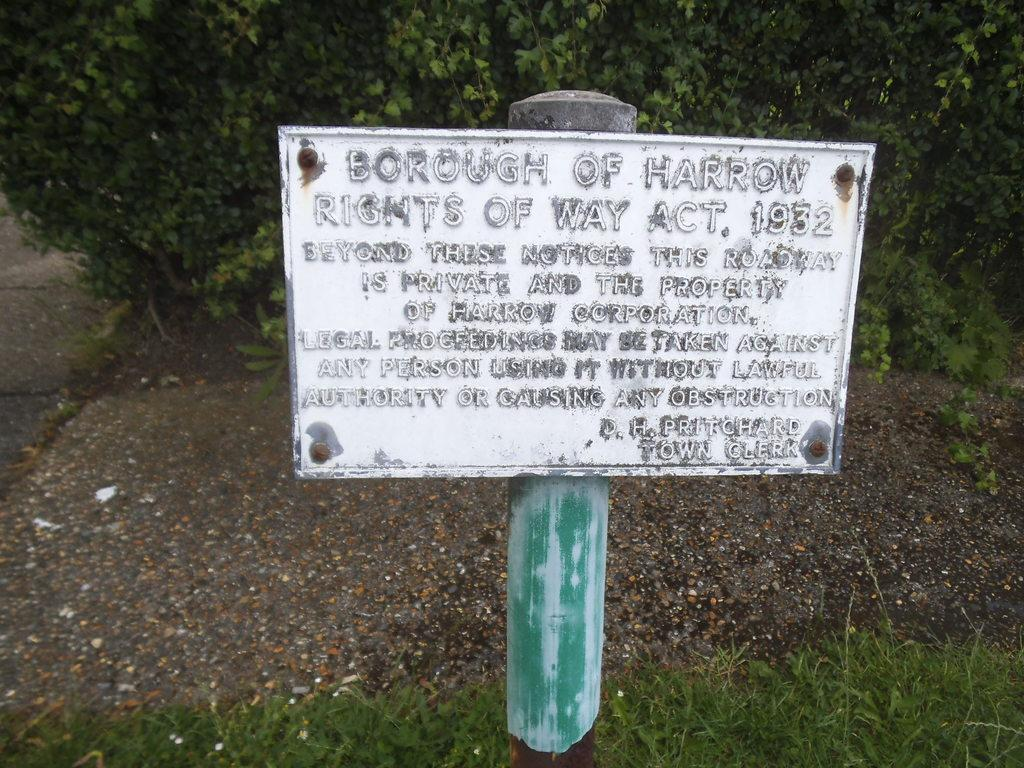What is the main object in the image? There is a pole in the image. What is attached to the pole? There is a name board attached to the pole. What can be seen in the background of the image? There are trees and the ground visible in the background of the image. What type of vegetation is present at the bottom of the image? There is grass at the bottom of the image. How many maids are visible in the image? There are no maids present in the image. What type of stem can be seen growing from the pole in the image? There is no stem growing from the pole in the image. 